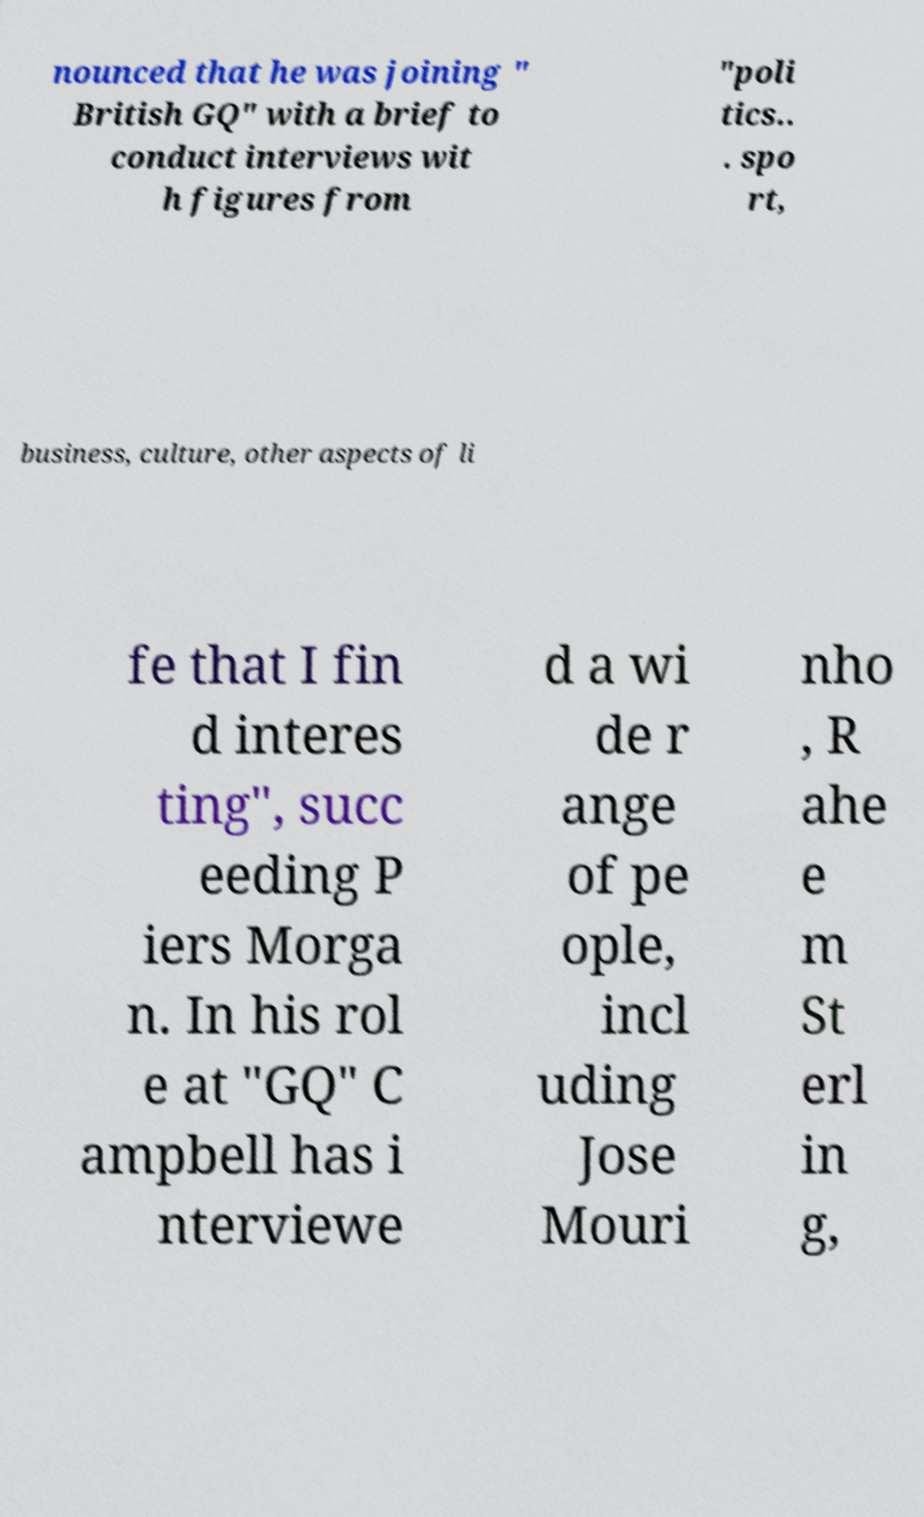Could you extract and type out the text from this image? nounced that he was joining " British GQ" with a brief to conduct interviews wit h figures from "poli tics.. . spo rt, business, culture, other aspects of li fe that I fin d interes ting", succ eeding P iers Morga n. In his rol e at "GQ" C ampbell has i nterviewe d a wi de r ange of pe ople, incl uding Jose Mouri nho , R ahe e m St erl in g, 